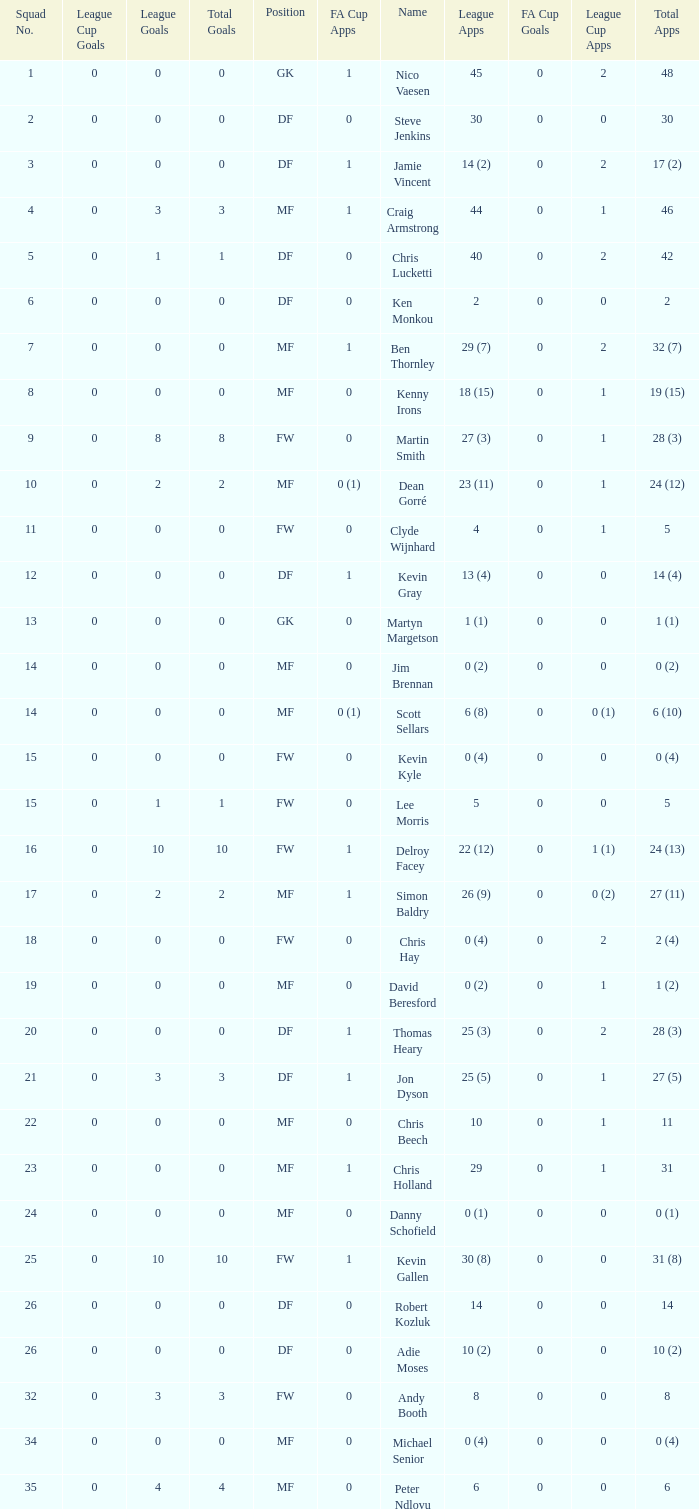Can you tell me the sum of FA Cup Goals that has the League Cup Goals larger than 0? None. 